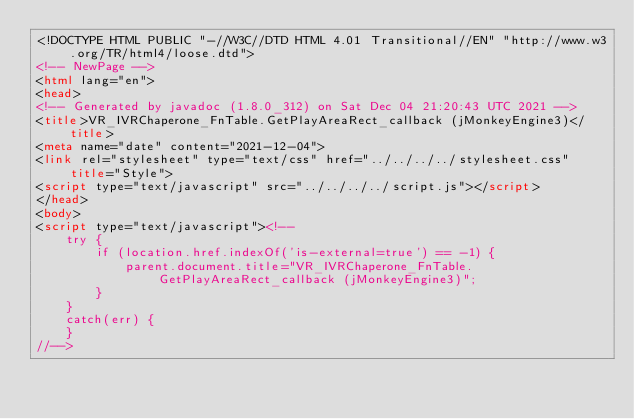Convert code to text. <code><loc_0><loc_0><loc_500><loc_500><_HTML_><!DOCTYPE HTML PUBLIC "-//W3C//DTD HTML 4.01 Transitional//EN" "http://www.w3.org/TR/html4/loose.dtd">
<!-- NewPage -->
<html lang="en">
<head>
<!-- Generated by javadoc (1.8.0_312) on Sat Dec 04 21:20:43 UTC 2021 -->
<title>VR_IVRChaperone_FnTable.GetPlayAreaRect_callback (jMonkeyEngine3)</title>
<meta name="date" content="2021-12-04">
<link rel="stylesheet" type="text/css" href="../../../../stylesheet.css" title="Style">
<script type="text/javascript" src="../../../../script.js"></script>
</head>
<body>
<script type="text/javascript"><!--
    try {
        if (location.href.indexOf('is-external=true') == -1) {
            parent.document.title="VR_IVRChaperone_FnTable.GetPlayAreaRect_callback (jMonkeyEngine3)";
        }
    }
    catch(err) {
    }
//--></code> 